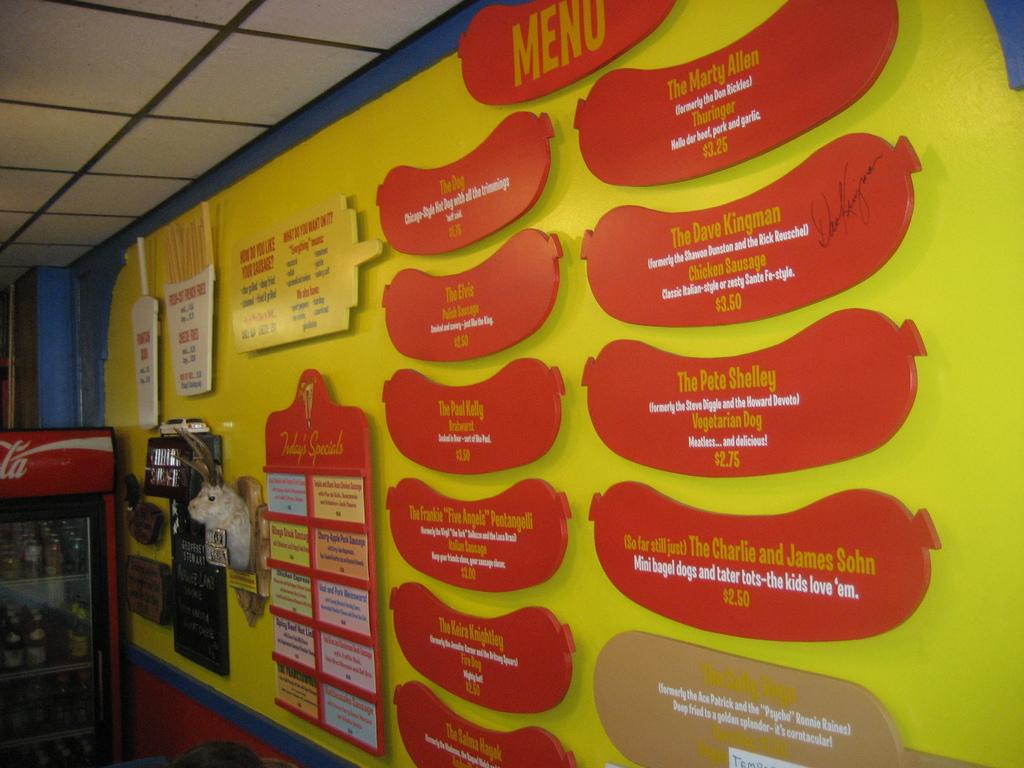Is this menu all they have?
Provide a short and direct response. Unanswerable. What is on the top red sign?
Keep it short and to the point. Menu. 